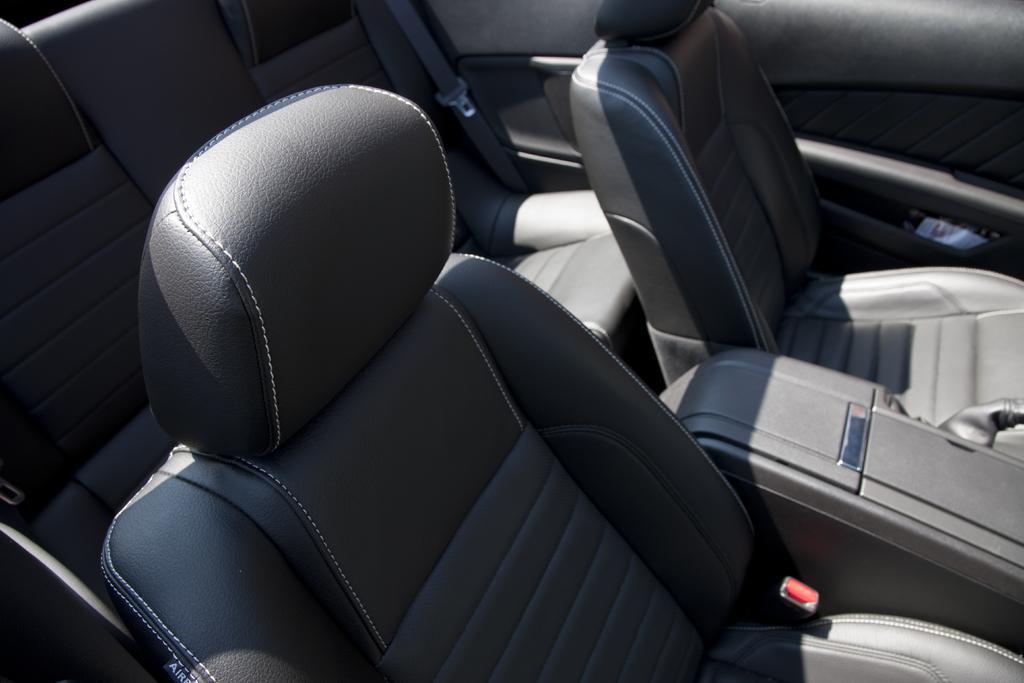Can you describe this image briefly? In this picture we can see seats, seat belts and some objects. 